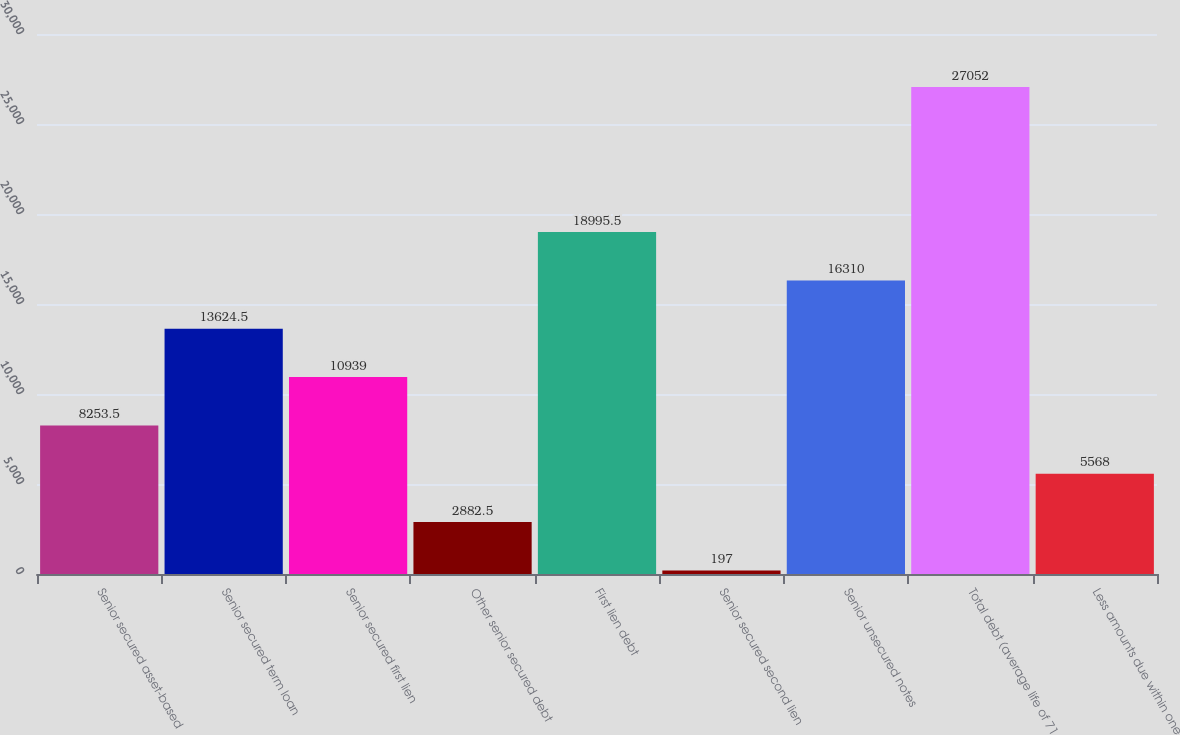Convert chart. <chart><loc_0><loc_0><loc_500><loc_500><bar_chart><fcel>Senior secured asset-based<fcel>Senior secured term loan<fcel>Senior secured first lien<fcel>Other senior secured debt<fcel>First lien debt<fcel>Senior secured second lien<fcel>Senior unsecured notes<fcel>Total debt (average life of 71<fcel>Less amounts due within one<nl><fcel>8253.5<fcel>13624.5<fcel>10939<fcel>2882.5<fcel>18995.5<fcel>197<fcel>16310<fcel>27052<fcel>5568<nl></chart> 